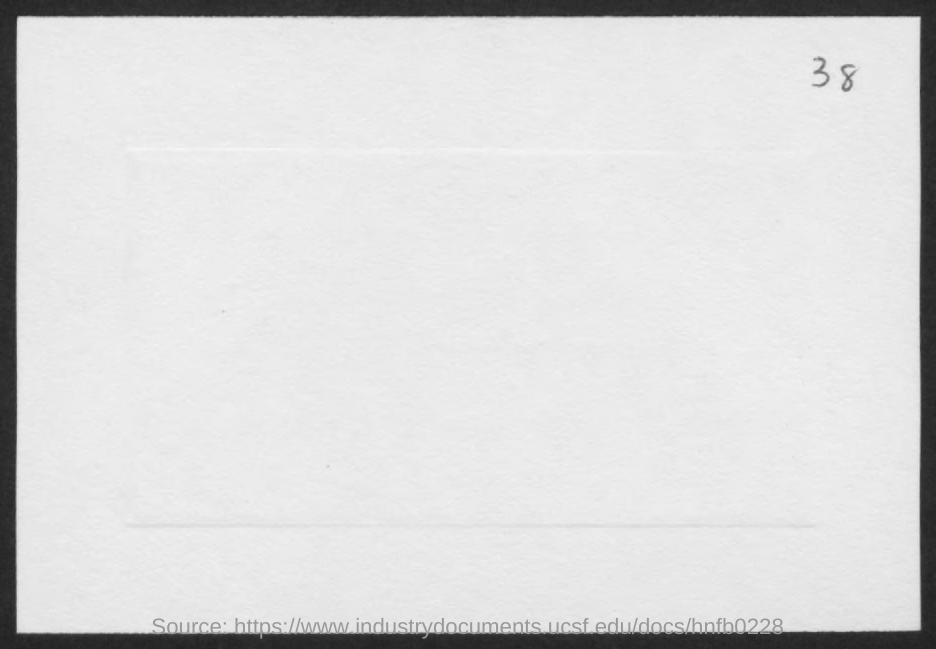Indicate a few pertinent items in this graphic. The page number is 38. 